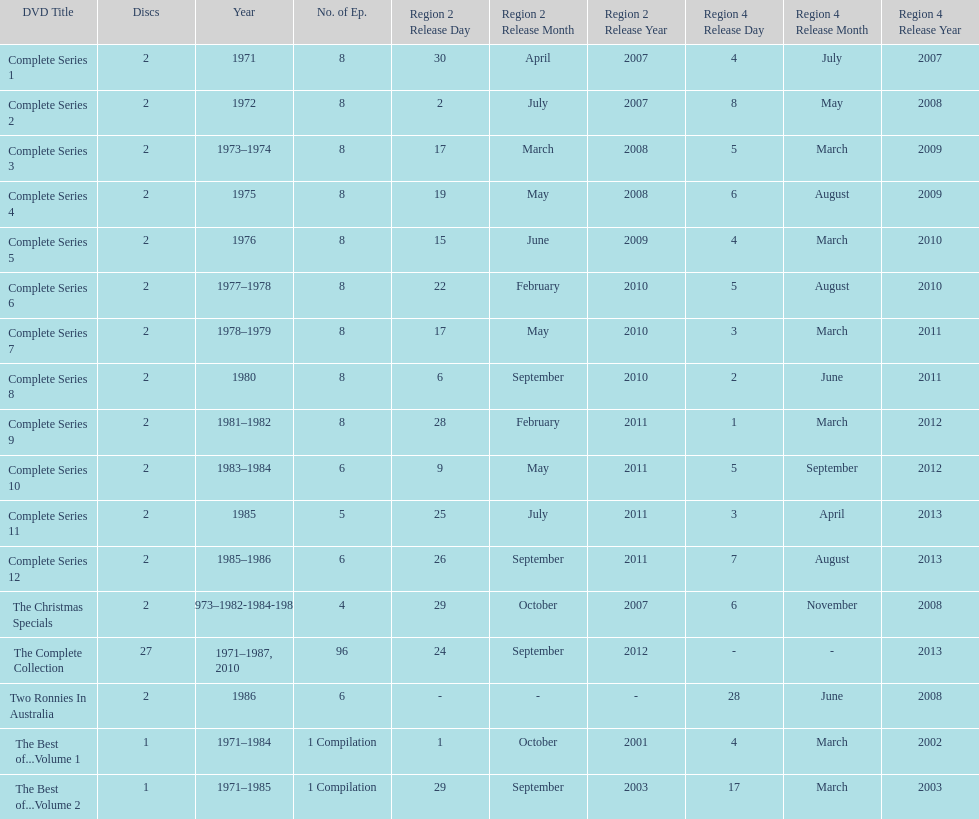What is previous to complete series 10? Complete Series 9. 